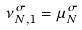Convert formula to latex. <formula><loc_0><loc_0><loc_500><loc_500>\nu _ { N , 1 } ^ { \sigma } = \mu _ { N } ^ { \sigma }</formula> 